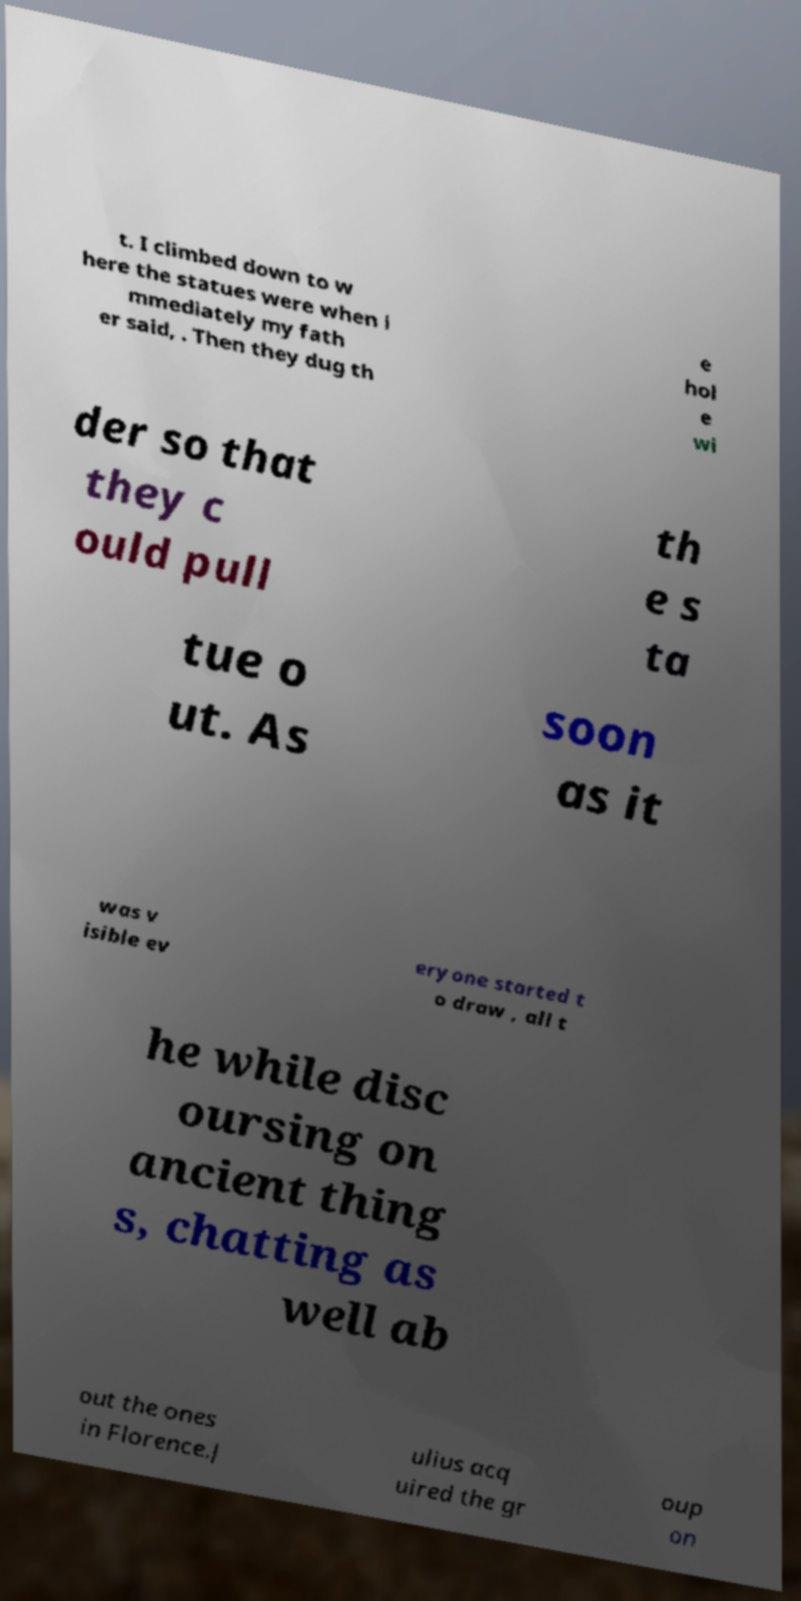For documentation purposes, I need the text within this image transcribed. Could you provide that? t. I climbed down to w here the statues were when i mmediately my fath er said, . Then they dug th e hol e wi der so that they c ould pull th e s ta tue o ut. As soon as it was v isible ev eryone started t o draw , all t he while disc oursing on ancient thing s, chatting as well ab out the ones in Florence.J ulius acq uired the gr oup on 